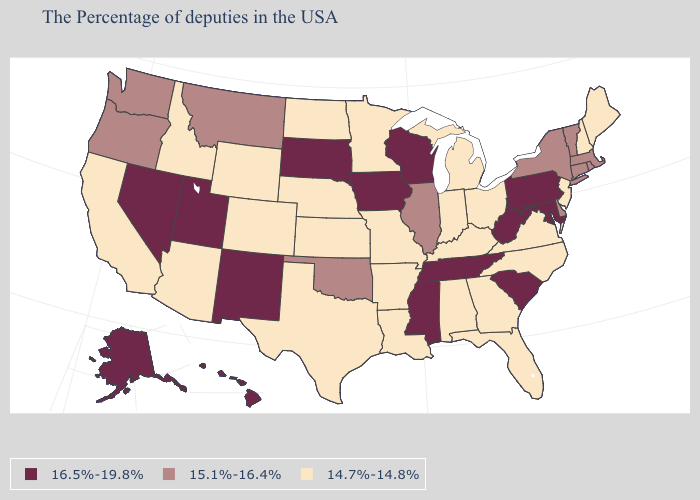Does the map have missing data?
Quick response, please. No. Name the states that have a value in the range 16.5%-19.8%?
Keep it brief. Maryland, Pennsylvania, South Carolina, West Virginia, Tennessee, Wisconsin, Mississippi, Iowa, South Dakota, New Mexico, Utah, Nevada, Alaska, Hawaii. Does Missouri have a lower value than New Hampshire?
Answer briefly. No. Is the legend a continuous bar?
Concise answer only. No. Name the states that have a value in the range 14.7%-14.8%?
Concise answer only. Maine, New Hampshire, New Jersey, Virginia, North Carolina, Ohio, Florida, Georgia, Michigan, Kentucky, Indiana, Alabama, Louisiana, Missouri, Arkansas, Minnesota, Kansas, Nebraska, Texas, North Dakota, Wyoming, Colorado, Arizona, Idaho, California. Name the states that have a value in the range 14.7%-14.8%?
Keep it brief. Maine, New Hampshire, New Jersey, Virginia, North Carolina, Ohio, Florida, Georgia, Michigan, Kentucky, Indiana, Alabama, Louisiana, Missouri, Arkansas, Minnesota, Kansas, Nebraska, Texas, North Dakota, Wyoming, Colorado, Arizona, Idaho, California. Among the states that border Colorado , which have the highest value?
Concise answer only. New Mexico, Utah. What is the value of Utah?
Quick response, please. 16.5%-19.8%. Name the states that have a value in the range 15.1%-16.4%?
Concise answer only. Massachusetts, Rhode Island, Vermont, Connecticut, New York, Delaware, Illinois, Oklahoma, Montana, Washington, Oregon. Name the states that have a value in the range 16.5%-19.8%?
Be succinct. Maryland, Pennsylvania, South Carolina, West Virginia, Tennessee, Wisconsin, Mississippi, Iowa, South Dakota, New Mexico, Utah, Nevada, Alaska, Hawaii. Name the states that have a value in the range 15.1%-16.4%?
Be succinct. Massachusetts, Rhode Island, Vermont, Connecticut, New York, Delaware, Illinois, Oklahoma, Montana, Washington, Oregon. Name the states that have a value in the range 14.7%-14.8%?
Quick response, please. Maine, New Hampshire, New Jersey, Virginia, North Carolina, Ohio, Florida, Georgia, Michigan, Kentucky, Indiana, Alabama, Louisiana, Missouri, Arkansas, Minnesota, Kansas, Nebraska, Texas, North Dakota, Wyoming, Colorado, Arizona, Idaho, California. Name the states that have a value in the range 15.1%-16.4%?
Give a very brief answer. Massachusetts, Rhode Island, Vermont, Connecticut, New York, Delaware, Illinois, Oklahoma, Montana, Washington, Oregon. Does the first symbol in the legend represent the smallest category?
Write a very short answer. No. Which states have the highest value in the USA?
Give a very brief answer. Maryland, Pennsylvania, South Carolina, West Virginia, Tennessee, Wisconsin, Mississippi, Iowa, South Dakota, New Mexico, Utah, Nevada, Alaska, Hawaii. 